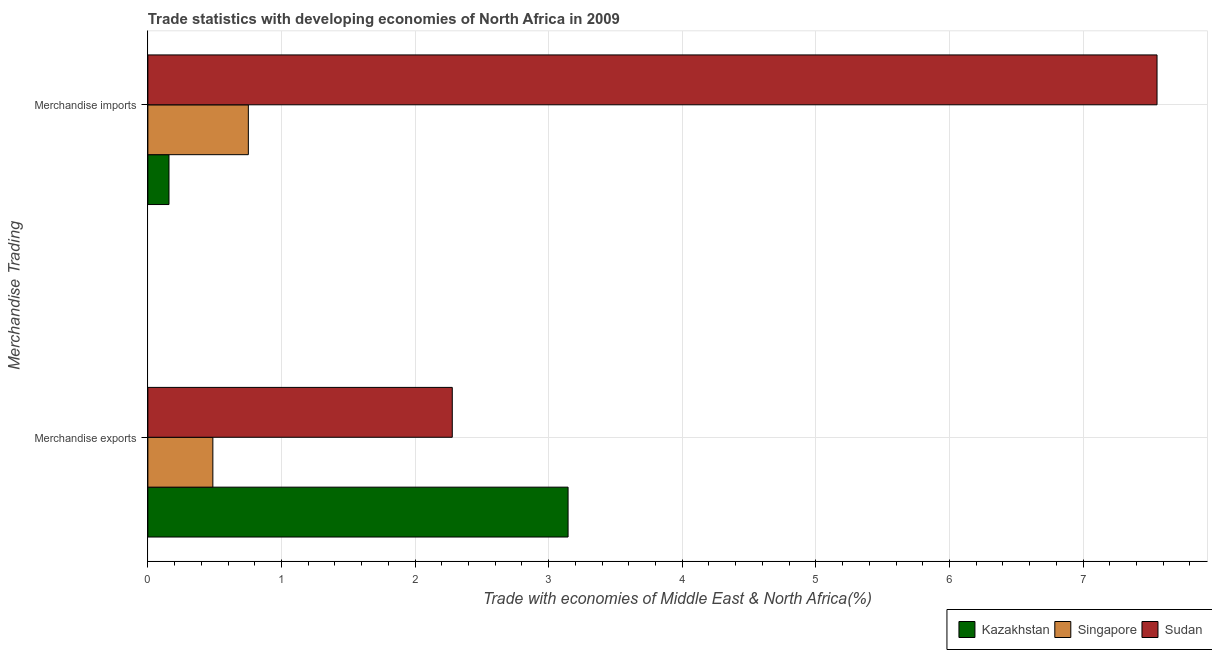How many groups of bars are there?
Provide a succinct answer. 2. Are the number of bars per tick equal to the number of legend labels?
Your answer should be very brief. Yes. Are the number of bars on each tick of the Y-axis equal?
Provide a succinct answer. Yes. How many bars are there on the 1st tick from the top?
Provide a short and direct response. 3. What is the label of the 1st group of bars from the top?
Keep it short and to the point. Merchandise imports. What is the merchandise exports in Singapore?
Your answer should be very brief. 0.49. Across all countries, what is the maximum merchandise imports?
Offer a very short reply. 7.55. Across all countries, what is the minimum merchandise exports?
Offer a terse response. 0.49. In which country was the merchandise exports maximum?
Your answer should be very brief. Kazakhstan. In which country was the merchandise exports minimum?
Your answer should be very brief. Singapore. What is the total merchandise imports in the graph?
Your response must be concise. 8.46. What is the difference between the merchandise exports in Singapore and that in Kazakhstan?
Offer a very short reply. -2.66. What is the difference between the merchandise exports in Sudan and the merchandise imports in Kazakhstan?
Keep it short and to the point. 2.12. What is the average merchandise exports per country?
Your response must be concise. 1.97. What is the difference between the merchandise exports and merchandise imports in Kazakhstan?
Your answer should be compact. 2.99. In how many countries, is the merchandise imports greater than 3.2 %?
Keep it short and to the point. 1. What is the ratio of the merchandise imports in Sudan to that in Singapore?
Offer a very short reply. 10.04. In how many countries, is the merchandise imports greater than the average merchandise imports taken over all countries?
Provide a succinct answer. 1. What does the 2nd bar from the top in Merchandise imports represents?
Your response must be concise. Singapore. What does the 3rd bar from the bottom in Merchandise imports represents?
Your answer should be compact. Sudan. How many bars are there?
Ensure brevity in your answer.  6. What is the difference between two consecutive major ticks on the X-axis?
Ensure brevity in your answer.  1. Does the graph contain any zero values?
Make the answer very short. No. Does the graph contain grids?
Ensure brevity in your answer.  Yes. What is the title of the graph?
Offer a very short reply. Trade statistics with developing economies of North Africa in 2009. Does "Botswana" appear as one of the legend labels in the graph?
Offer a very short reply. No. What is the label or title of the X-axis?
Make the answer very short. Trade with economies of Middle East & North Africa(%). What is the label or title of the Y-axis?
Offer a terse response. Merchandise Trading. What is the Trade with economies of Middle East & North Africa(%) in Kazakhstan in Merchandise exports?
Your answer should be compact. 3.15. What is the Trade with economies of Middle East & North Africa(%) of Singapore in Merchandise exports?
Your answer should be compact. 0.49. What is the Trade with economies of Middle East & North Africa(%) in Sudan in Merchandise exports?
Your answer should be compact. 2.28. What is the Trade with economies of Middle East & North Africa(%) of Kazakhstan in Merchandise imports?
Make the answer very short. 0.16. What is the Trade with economies of Middle East & North Africa(%) of Singapore in Merchandise imports?
Your answer should be compact. 0.75. What is the Trade with economies of Middle East & North Africa(%) of Sudan in Merchandise imports?
Provide a short and direct response. 7.55. Across all Merchandise Trading, what is the maximum Trade with economies of Middle East & North Africa(%) in Kazakhstan?
Give a very brief answer. 3.15. Across all Merchandise Trading, what is the maximum Trade with economies of Middle East & North Africa(%) of Singapore?
Keep it short and to the point. 0.75. Across all Merchandise Trading, what is the maximum Trade with economies of Middle East & North Africa(%) of Sudan?
Provide a short and direct response. 7.55. Across all Merchandise Trading, what is the minimum Trade with economies of Middle East & North Africa(%) of Kazakhstan?
Give a very brief answer. 0.16. Across all Merchandise Trading, what is the minimum Trade with economies of Middle East & North Africa(%) of Singapore?
Your response must be concise. 0.49. Across all Merchandise Trading, what is the minimum Trade with economies of Middle East & North Africa(%) of Sudan?
Provide a succinct answer. 2.28. What is the total Trade with economies of Middle East & North Africa(%) in Kazakhstan in the graph?
Provide a succinct answer. 3.3. What is the total Trade with economies of Middle East & North Africa(%) of Singapore in the graph?
Your response must be concise. 1.24. What is the total Trade with economies of Middle East & North Africa(%) of Sudan in the graph?
Your response must be concise. 9.83. What is the difference between the Trade with economies of Middle East & North Africa(%) of Kazakhstan in Merchandise exports and that in Merchandise imports?
Provide a succinct answer. 2.99. What is the difference between the Trade with economies of Middle East & North Africa(%) of Singapore in Merchandise exports and that in Merchandise imports?
Keep it short and to the point. -0.27. What is the difference between the Trade with economies of Middle East & North Africa(%) in Sudan in Merchandise exports and that in Merchandise imports?
Provide a succinct answer. -5.28. What is the difference between the Trade with economies of Middle East & North Africa(%) of Kazakhstan in Merchandise exports and the Trade with economies of Middle East & North Africa(%) of Singapore in Merchandise imports?
Offer a very short reply. 2.39. What is the difference between the Trade with economies of Middle East & North Africa(%) in Kazakhstan in Merchandise exports and the Trade with economies of Middle East & North Africa(%) in Sudan in Merchandise imports?
Your response must be concise. -4.41. What is the difference between the Trade with economies of Middle East & North Africa(%) of Singapore in Merchandise exports and the Trade with economies of Middle East & North Africa(%) of Sudan in Merchandise imports?
Offer a terse response. -7.07. What is the average Trade with economies of Middle East & North Africa(%) in Kazakhstan per Merchandise Trading?
Offer a terse response. 1.65. What is the average Trade with economies of Middle East & North Africa(%) in Singapore per Merchandise Trading?
Provide a succinct answer. 0.62. What is the average Trade with economies of Middle East & North Africa(%) of Sudan per Merchandise Trading?
Provide a succinct answer. 4.92. What is the difference between the Trade with economies of Middle East & North Africa(%) of Kazakhstan and Trade with economies of Middle East & North Africa(%) of Singapore in Merchandise exports?
Your answer should be very brief. 2.66. What is the difference between the Trade with economies of Middle East & North Africa(%) of Kazakhstan and Trade with economies of Middle East & North Africa(%) of Sudan in Merchandise exports?
Give a very brief answer. 0.87. What is the difference between the Trade with economies of Middle East & North Africa(%) of Singapore and Trade with economies of Middle East & North Africa(%) of Sudan in Merchandise exports?
Offer a very short reply. -1.79. What is the difference between the Trade with economies of Middle East & North Africa(%) in Kazakhstan and Trade with economies of Middle East & North Africa(%) in Singapore in Merchandise imports?
Provide a short and direct response. -0.59. What is the difference between the Trade with economies of Middle East & North Africa(%) of Kazakhstan and Trade with economies of Middle East & North Africa(%) of Sudan in Merchandise imports?
Offer a terse response. -7.4. What is the difference between the Trade with economies of Middle East & North Africa(%) of Singapore and Trade with economies of Middle East & North Africa(%) of Sudan in Merchandise imports?
Provide a short and direct response. -6.8. What is the ratio of the Trade with economies of Middle East & North Africa(%) of Kazakhstan in Merchandise exports to that in Merchandise imports?
Give a very brief answer. 19.89. What is the ratio of the Trade with economies of Middle East & North Africa(%) in Singapore in Merchandise exports to that in Merchandise imports?
Ensure brevity in your answer.  0.65. What is the ratio of the Trade with economies of Middle East & North Africa(%) in Sudan in Merchandise exports to that in Merchandise imports?
Your response must be concise. 0.3. What is the difference between the highest and the second highest Trade with economies of Middle East & North Africa(%) in Kazakhstan?
Provide a succinct answer. 2.99. What is the difference between the highest and the second highest Trade with economies of Middle East & North Africa(%) in Singapore?
Your response must be concise. 0.27. What is the difference between the highest and the second highest Trade with economies of Middle East & North Africa(%) of Sudan?
Provide a succinct answer. 5.28. What is the difference between the highest and the lowest Trade with economies of Middle East & North Africa(%) of Kazakhstan?
Keep it short and to the point. 2.99. What is the difference between the highest and the lowest Trade with economies of Middle East & North Africa(%) of Singapore?
Offer a very short reply. 0.27. What is the difference between the highest and the lowest Trade with economies of Middle East & North Africa(%) of Sudan?
Provide a short and direct response. 5.28. 